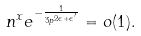Convert formula to latex. <formula><loc_0><loc_0><loc_500><loc_500>n ^ { x } e ^ { - \frac { 1 } { 3 p ^ { 2 \epsilon + \epsilon ^ { \prime } } } } = o ( 1 ) .</formula> 